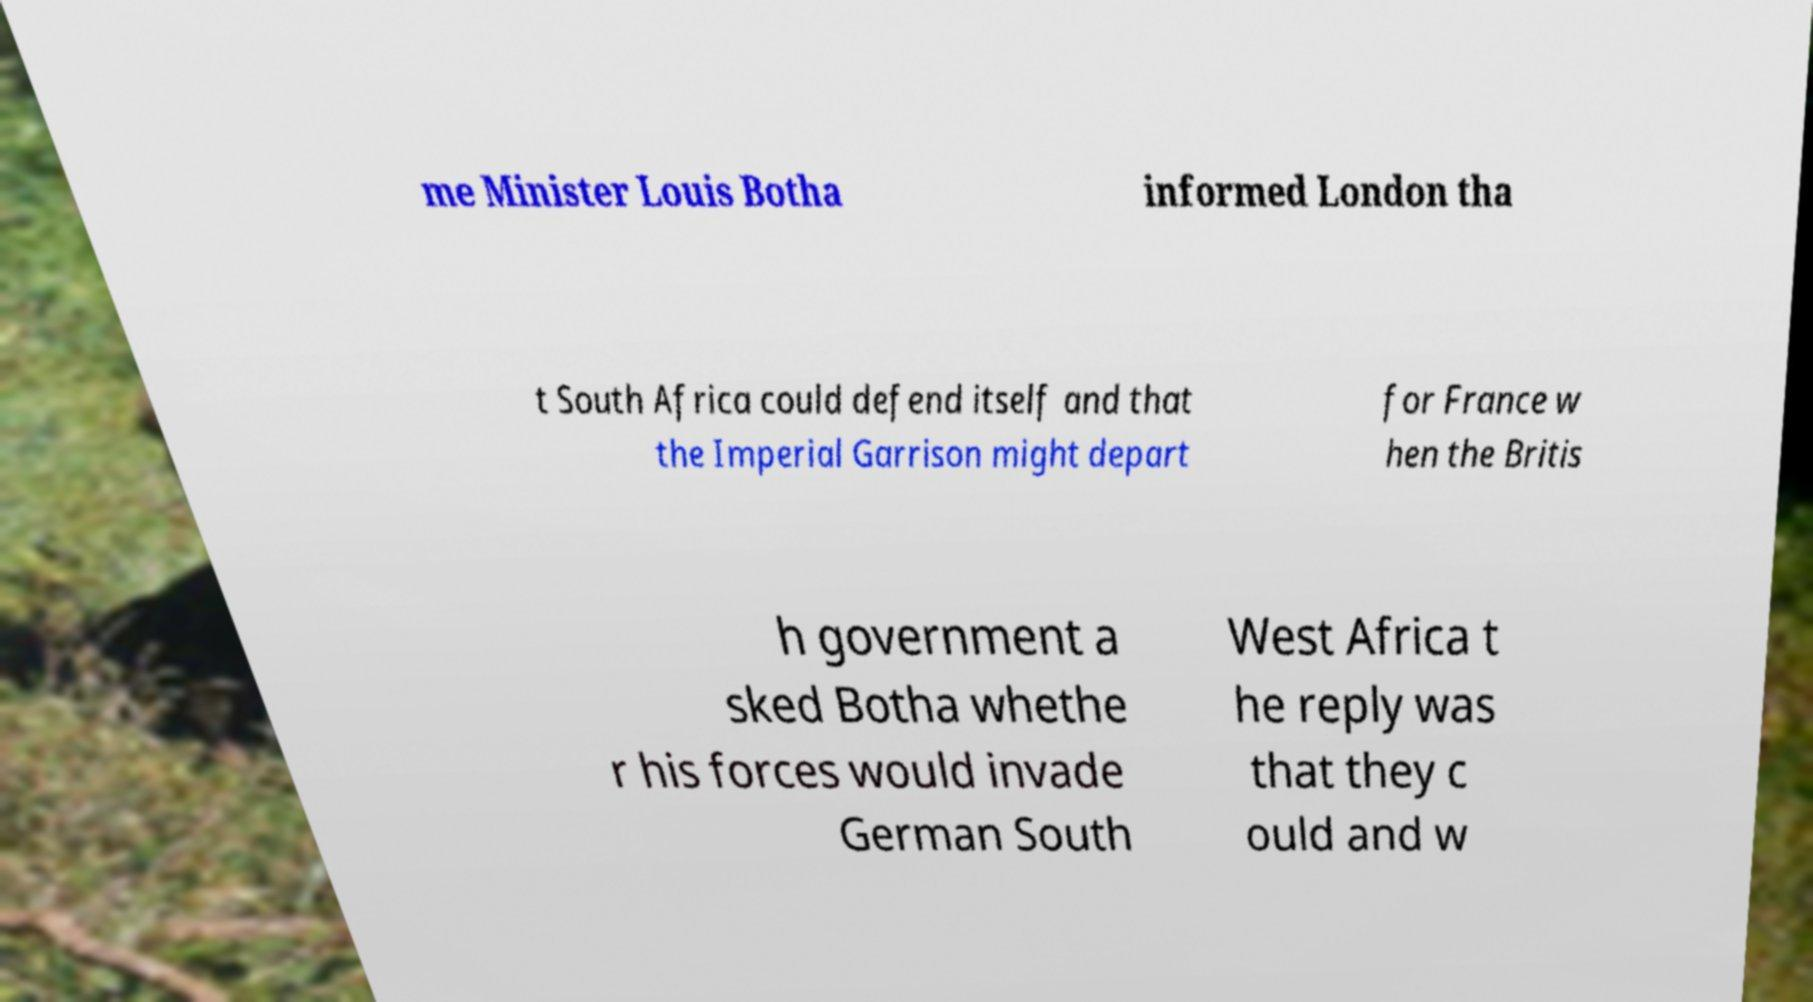Please read and relay the text visible in this image. What does it say? me Minister Louis Botha informed London tha t South Africa could defend itself and that the Imperial Garrison might depart for France w hen the Britis h government a sked Botha whethe r his forces would invade German South West Africa t he reply was that they c ould and w 